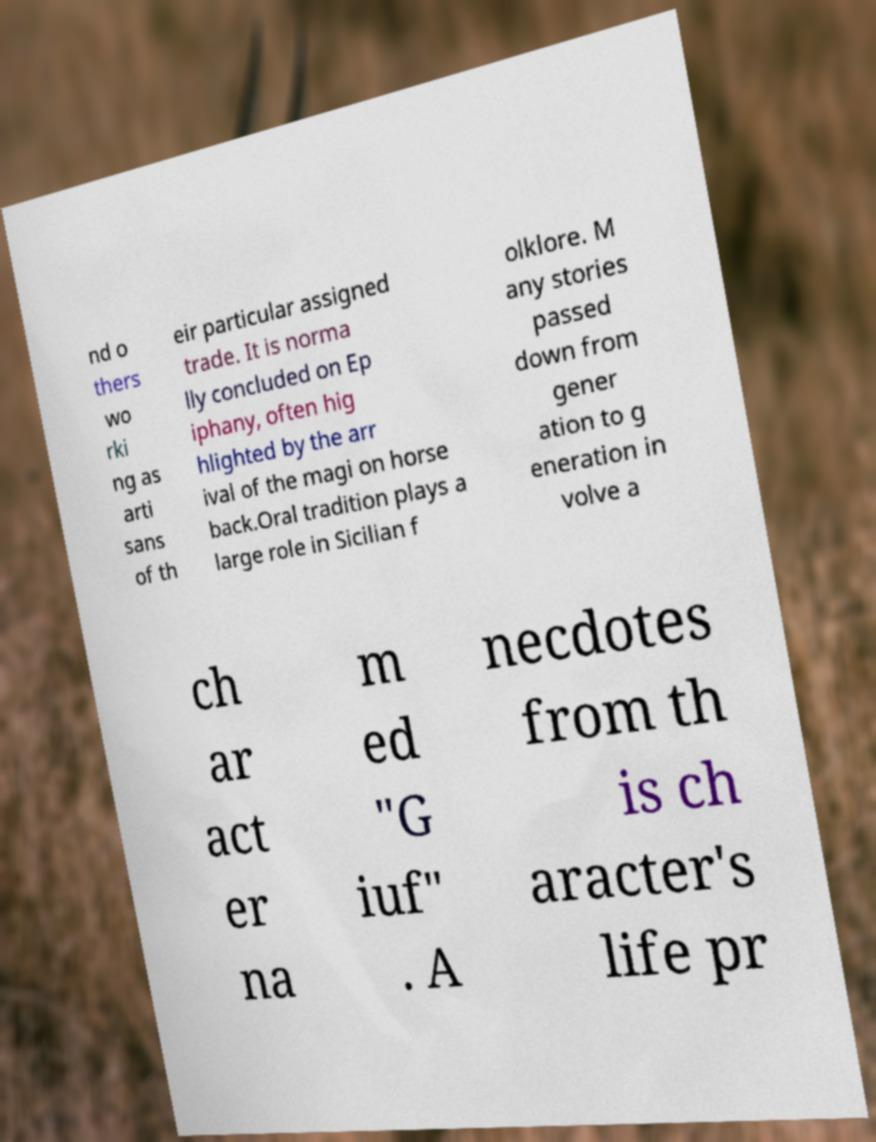Please read and relay the text visible in this image. What does it say? nd o thers wo rki ng as arti sans of th eir particular assigned trade. It is norma lly concluded on Ep iphany, often hig hlighted by the arr ival of the magi on horse back.Oral tradition plays a large role in Sicilian f olklore. M any stories passed down from gener ation to g eneration in volve a ch ar act er na m ed "G iuf" . A necdotes from th is ch aracter's life pr 